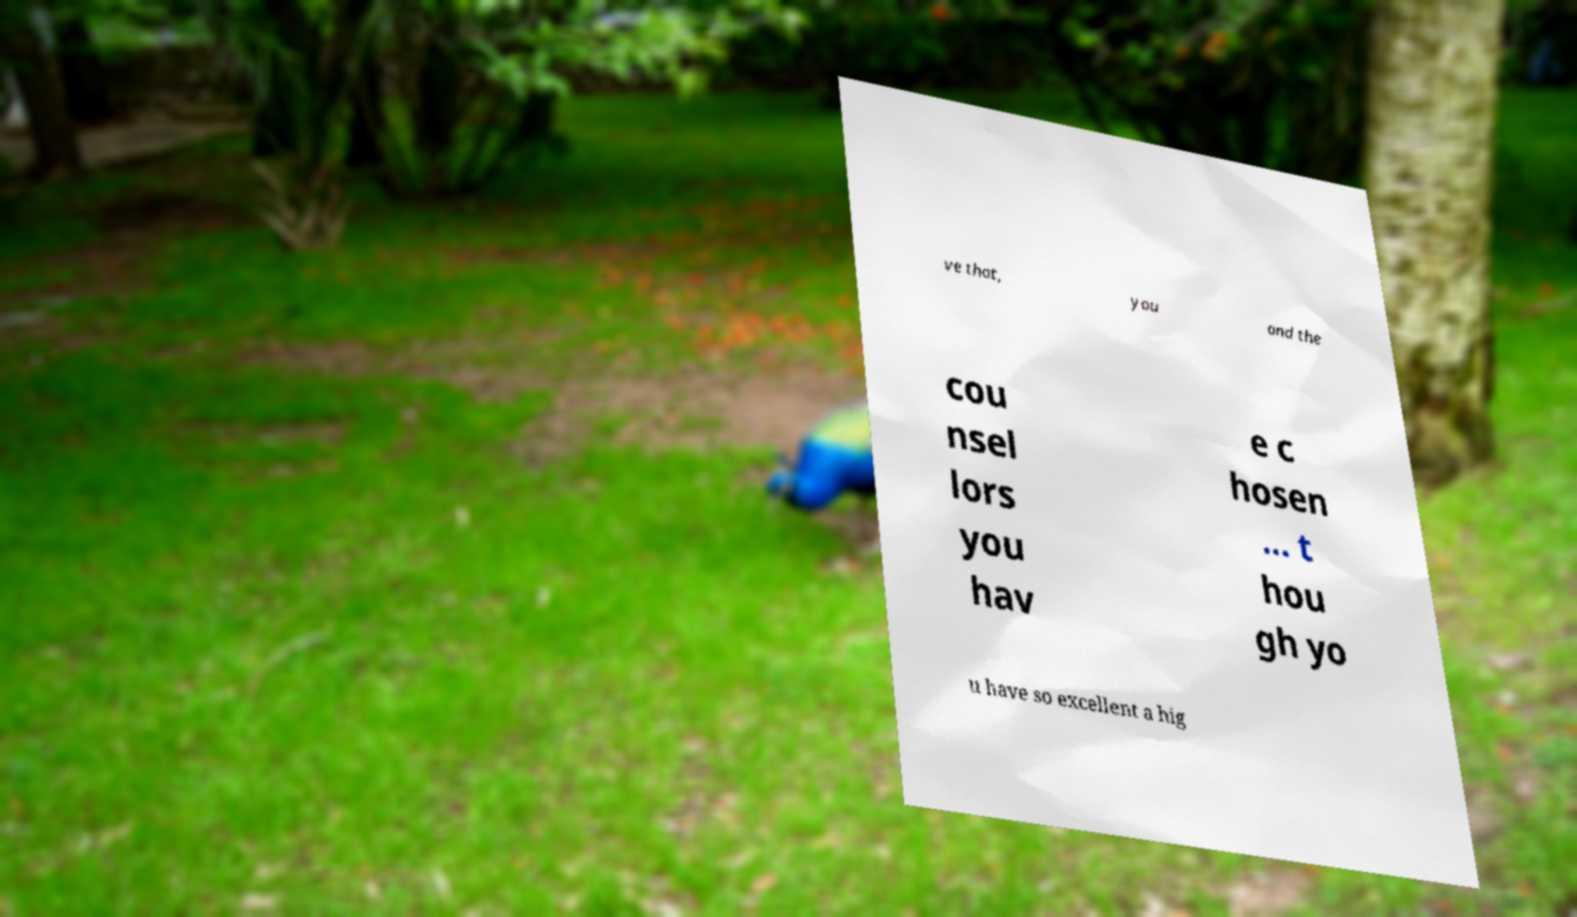Please read and relay the text visible in this image. What does it say? ve that, you and the cou nsel lors you hav e c hosen ... t hou gh yo u have so excellent a hig 